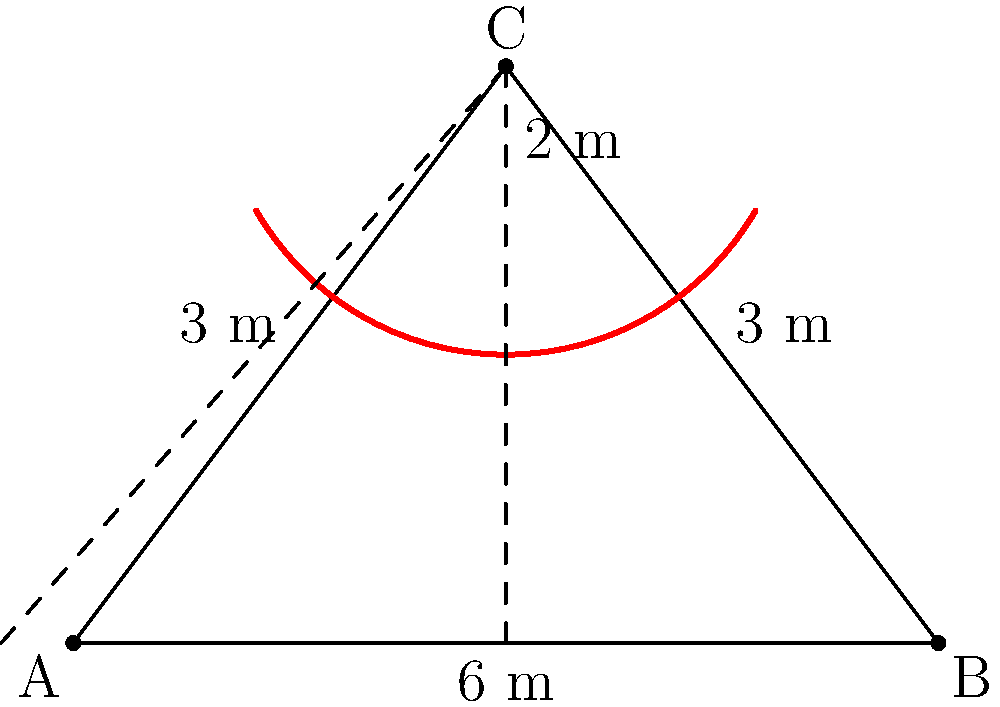To celebrate your 10th wedding anniversary, you and your spouse decide to build a heart-shaped arch in your garden. The base of the arch is 6 meters wide, and the two sides of the triangle forming the arch are each 3 meters long. At the top of the arch, there's a curved section with a radius of 2 meters. Calculate the total height of the arch from the ground to its highest point. Let's approach this step-by-step:

1) First, we need to find the height of the triangle formed by the two sides of the arch.

2) This is an isosceles triangle with base 6 m and two sides of 3 m each.

3) We can split this into two right triangles. Let's focus on one:
   - The base of this right triangle is 3 m (half of 6 m)
   - The hypotenuse is 3 m

4) We can use the Pythagorean theorem to find the height (let's call it $h$):

   $3^2 = 3^2 + h^2$
   $9 = 9 + h^2$
   $h^2 = 9 - 9 = 0$
   $h = \sqrt{0} = 0$

5) However, this result doesn't make sense in reality. The issue is that our triangle is actually a straight line (6 m long) when we try to make it with two 3 m sides.

6) In a real-world scenario, you'd need to adjust the measurements to form a proper triangle. Let's assume the base is slightly less than 6 m, say 5.8 m, to allow for a triangular shape.

7) Now, with a base of 5.8 m (2.9 m for each half):

   $3^2 = 2.9^2 + h^2$
   $9 = 8.41 + h^2$
   $h^2 = 0.59$
   $h = \sqrt{0.59} \approx 0.77$ m

8) So the height of the triangle is approximately 0.77 m.

9) Now, we need to add the radius of the curved section at the top, which is 2 m.

10) Total height = Height of triangle + Radius of curve
                 $\approx 0.77 + 2 = 2.77$ m

Therefore, the total height of the arch is approximately 2.77 meters.
Answer: $2.77$ m 